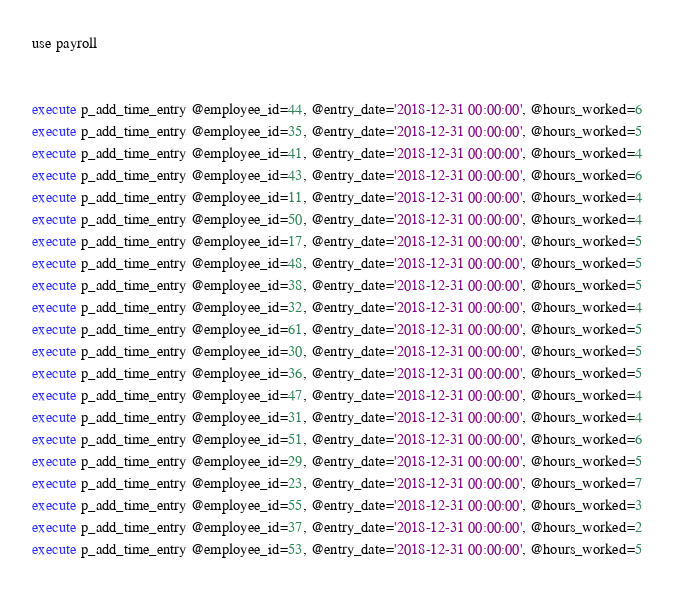Convert code to text. <code><loc_0><loc_0><loc_500><loc_500><_SQL_>use payroll


execute p_add_time_entry @employee_id=44, @entry_date='2018-12-31 00:00:00', @hours_worked=6
execute p_add_time_entry @employee_id=35, @entry_date='2018-12-31 00:00:00', @hours_worked=5
execute p_add_time_entry @employee_id=41, @entry_date='2018-12-31 00:00:00', @hours_worked=4
execute p_add_time_entry @employee_id=43, @entry_date='2018-12-31 00:00:00', @hours_worked=6
execute p_add_time_entry @employee_id=11, @entry_date='2018-12-31 00:00:00', @hours_worked=4
execute p_add_time_entry @employee_id=50, @entry_date='2018-12-31 00:00:00', @hours_worked=4
execute p_add_time_entry @employee_id=17, @entry_date='2018-12-31 00:00:00', @hours_worked=5
execute p_add_time_entry @employee_id=48, @entry_date='2018-12-31 00:00:00', @hours_worked=5
execute p_add_time_entry @employee_id=38, @entry_date='2018-12-31 00:00:00', @hours_worked=5
execute p_add_time_entry @employee_id=32, @entry_date='2018-12-31 00:00:00', @hours_worked=4
execute p_add_time_entry @employee_id=61, @entry_date='2018-12-31 00:00:00', @hours_worked=5
execute p_add_time_entry @employee_id=30, @entry_date='2018-12-31 00:00:00', @hours_worked=5
execute p_add_time_entry @employee_id=36, @entry_date='2018-12-31 00:00:00', @hours_worked=5
execute p_add_time_entry @employee_id=47, @entry_date='2018-12-31 00:00:00', @hours_worked=4
execute p_add_time_entry @employee_id=31, @entry_date='2018-12-31 00:00:00', @hours_worked=4
execute p_add_time_entry @employee_id=51, @entry_date='2018-12-31 00:00:00', @hours_worked=6
execute p_add_time_entry @employee_id=29, @entry_date='2018-12-31 00:00:00', @hours_worked=5
execute p_add_time_entry @employee_id=23, @entry_date='2018-12-31 00:00:00', @hours_worked=7
execute p_add_time_entry @employee_id=55, @entry_date='2018-12-31 00:00:00', @hours_worked=3
execute p_add_time_entry @employee_id=37, @entry_date='2018-12-31 00:00:00', @hours_worked=2
execute p_add_time_entry @employee_id=53, @entry_date='2018-12-31 00:00:00', @hours_worked=5

</code> 